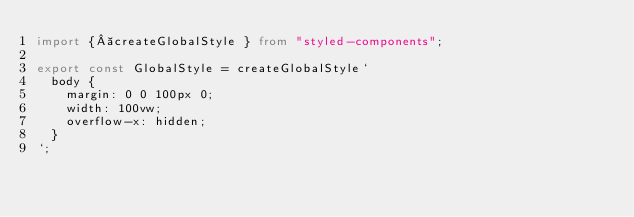Convert code to text. <code><loc_0><loc_0><loc_500><loc_500><_TypeScript_>import { createGlobalStyle } from "styled-components";

export const GlobalStyle = createGlobalStyle`
  body {
    margin: 0 0 100px 0;
    width: 100vw;
    overflow-x: hidden;
  }
`;
</code> 